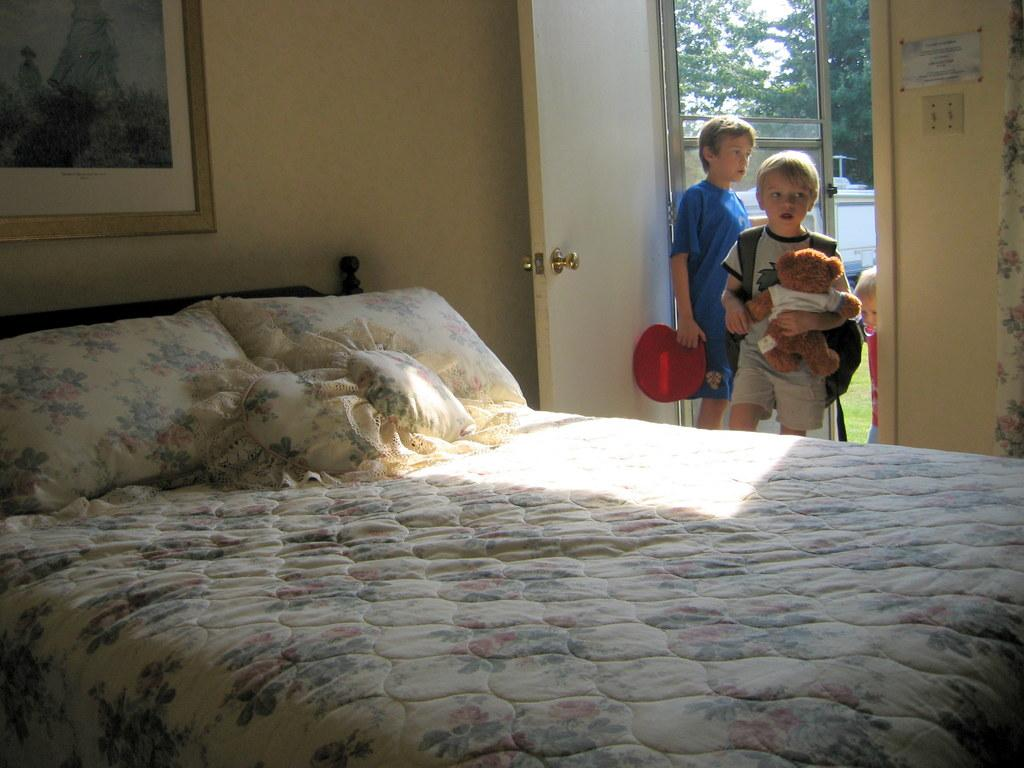How many people are entering the room in the image? Three people are entering a room in the image. What furniture is present in the room? There is a bed and a frame in the room. What can be seen outside the room? Trees and the sky are visible outside the room. What type of rock is being used as a musical instrument by one of the people entering the room? There is no rock being used as a musical instrument in the image. How does the journey of the people entering the room affect the room's appearance? The image does not show the journey of the people entering the room, so we cannot determine how it affects the room's appearance. 